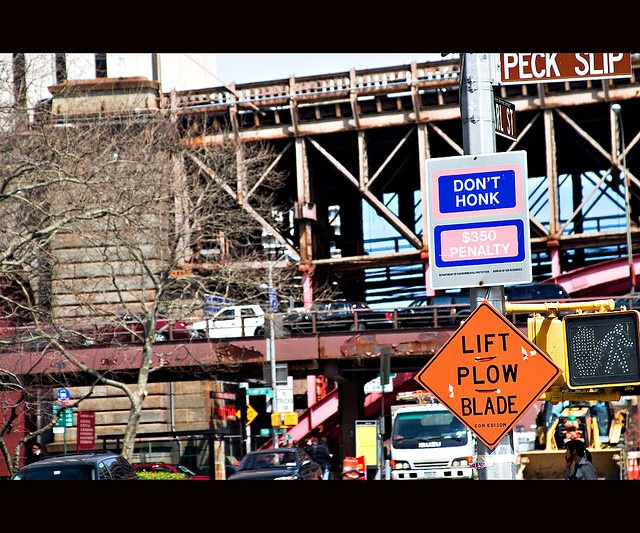Describe the objects in this image and their specific colors. I can see truck in black, white, navy, and blue tones, traffic light in black, gray, and purple tones, car in black, gray, darkgray, and navy tones, car in black, gray, navy, and blue tones, and car in black, gray, navy, and darkgray tones in this image. 